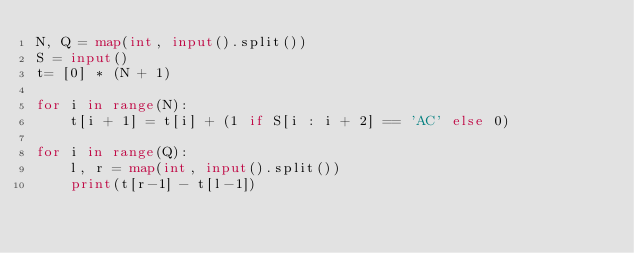Convert code to text. <code><loc_0><loc_0><loc_500><loc_500><_Python_>N, Q = map(int, input().split())
S = input()
t= [0] * (N + 1)

for i in range(N):
    t[i + 1] = t[i] + (1 if S[i : i + 2] == 'AC' else 0)

for i in range(Q):
    l, r = map(int, input().split())
    print(t[r-1] - t[l-1])
</code> 